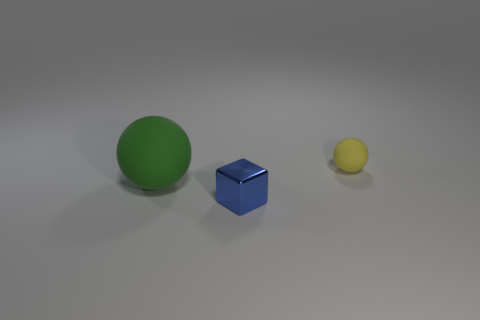Do the object that is on the right side of the blue cube and the object that is in front of the green matte thing have the same size?
Offer a terse response. Yes. There is a object that is in front of the matte thing that is to the left of the small blue cube; is there a tiny blue block that is on the left side of it?
Offer a very short reply. No. Is the number of small metal cubes to the left of the metal cube less than the number of tiny yellow matte objects on the right side of the yellow matte sphere?
Make the answer very short. No. The thing that is the same material as the small yellow sphere is what shape?
Provide a short and direct response. Sphere. There is a sphere that is in front of the small object that is right of the small object in front of the small matte object; what is its size?
Make the answer very short. Large. Are there more blue metal objects than matte balls?
Your answer should be compact. No. Do the ball that is right of the green rubber object and the green ball that is behind the blue shiny cube have the same material?
Make the answer very short. Yes. What number of metal things are the same size as the yellow rubber object?
Your answer should be compact. 1. Is the number of balls less than the number of tiny metal objects?
Provide a short and direct response. No. There is a rubber thing that is behind the green matte object that is in front of the small yellow ball; what is its shape?
Make the answer very short. Sphere. 